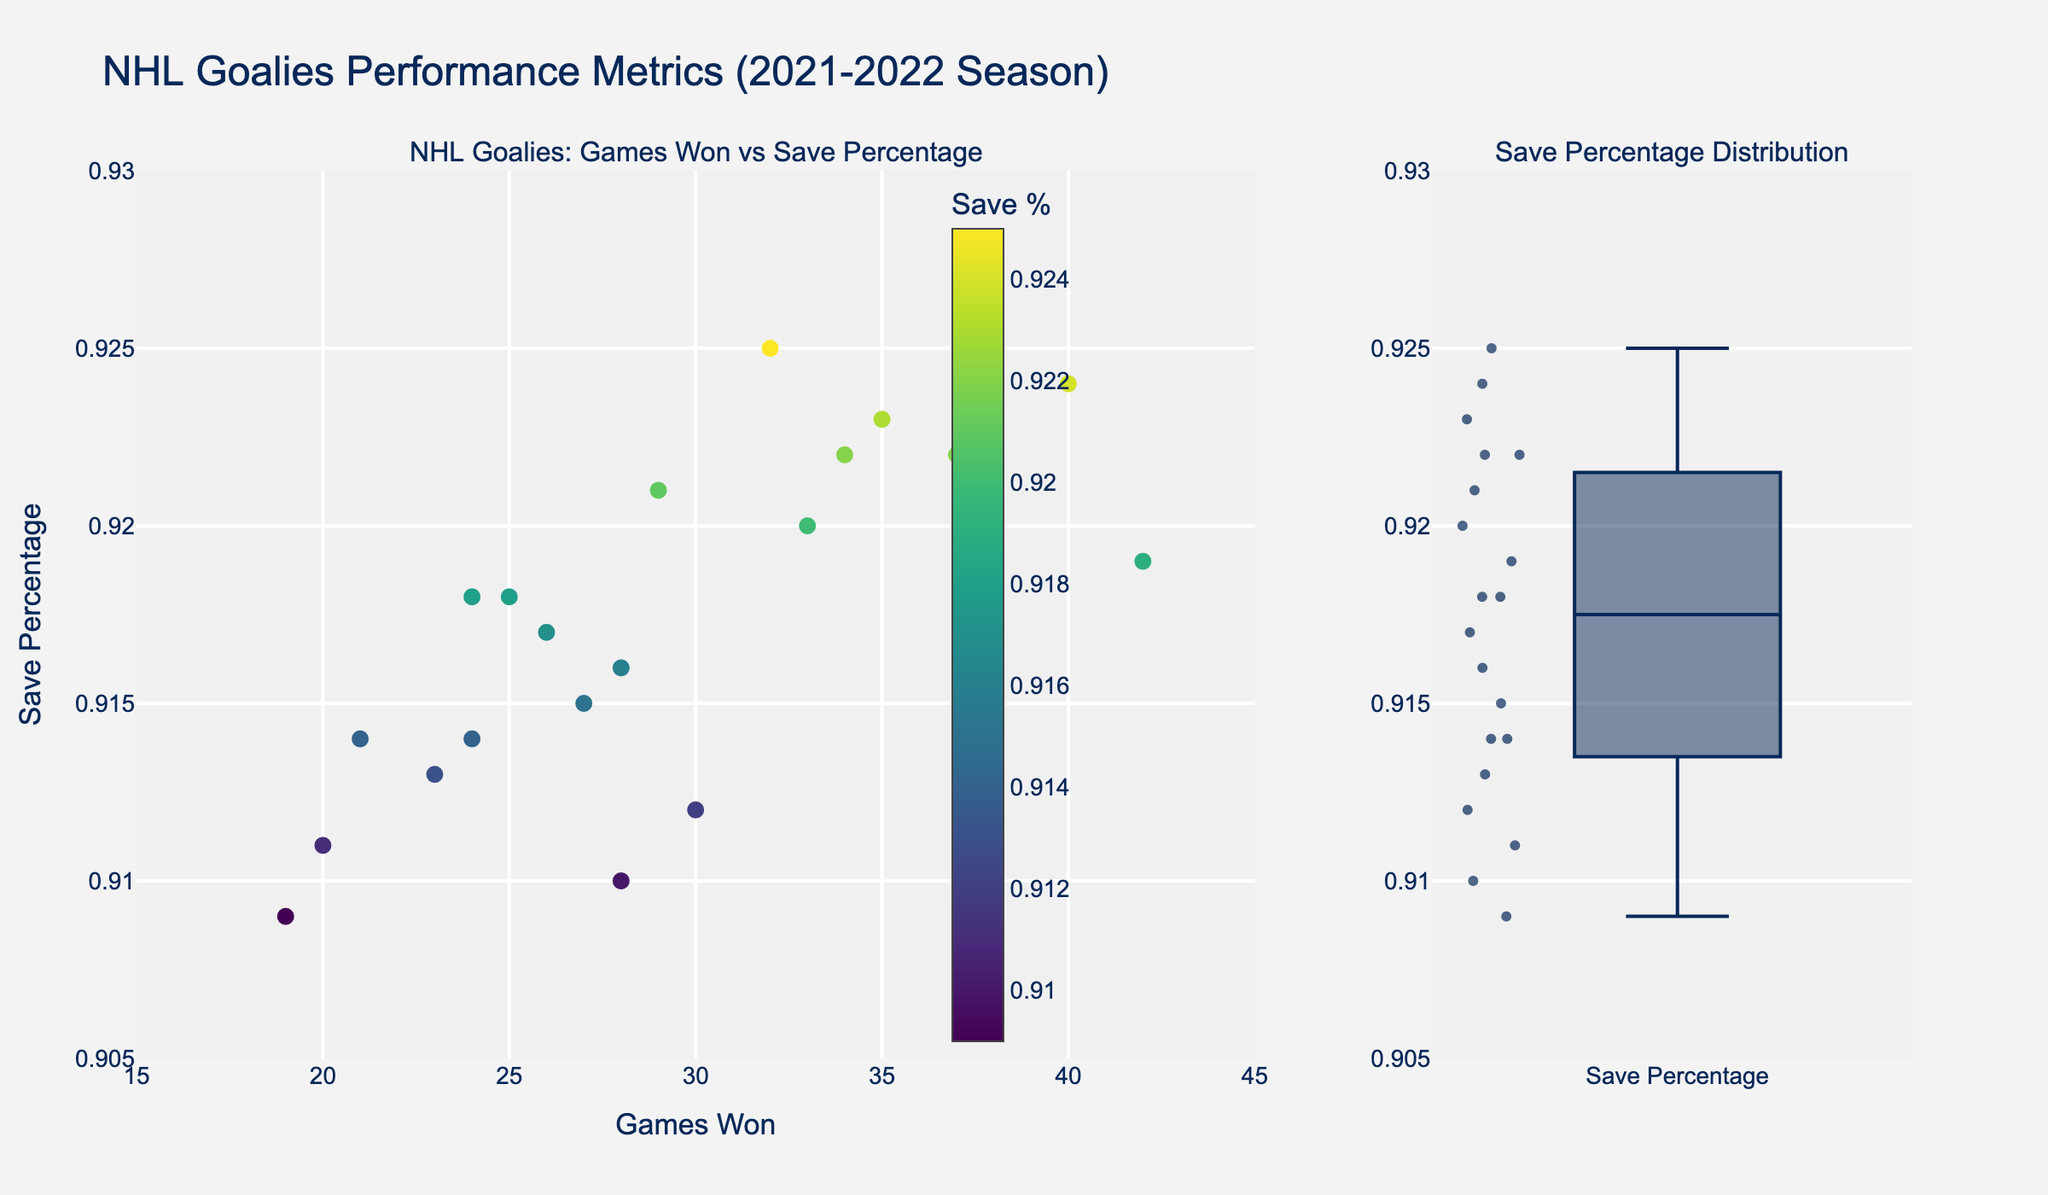what is the title of the plot? The title is the text displayed at the top of the plot. It describes the overview of what is being visualized.
Answer: NHL Goalies Performance Metrics (2021-2022 Season) How many goalies have their save percentage above 0.92? Look at the scatter plot for points above the 0.92 line. Alternatively, also check the save percentages distribution box plot and count the points above 0.92.
Answer: 7 Who has the highest save percentage? Identify the point closest to the upper y-axis boundary in both plots, scatter plot with goalie names and box plot showing all data points.
Answer: Ilya Sorokin What is the range of Games Won in the scatter plot? Examine the x-axis from the minimum to maximum points in the scatter plot for Games Won.
Answer: 19 to 42 Which goalie has won the most games? Identify the point farthest to the right on the x-axis in the scatter plot, and check the name associated.
Answer: Andrei Vasilevskiy What is the median save percentage according to the box plot? Look at the line inside the box of the Save Percentage box plot. This line represents the median value of the data.
Answer: Approximately 0.917 How does the save percentage of Igor Shesterkin compare to Frederik Andersen? Compare the y-values of Igor Shesterkin and Frederik Andersen in the scatter plot.
Answer: Igor Shesterkin's save percentage is higher Which goalie's save percentage is closest to the average save percentage? Calculate the average save percentage from all points plotted in the Save Percentage box plot by visually approximating the middle of the data spread. Compare individual points to determine proximity.
Answer: Tuukka Rask What is the color used to denote save percentage in the scatter plot color scale? Check the colorbar alongside the scatter plot indicating the scale.
Answer: Viridis colorscale Are there any goalies with identical save percentages? Look for overlapping points in the scatter plot or closely positioned points in the box plot segment.
Answer: Yes, Tuukka Rask and Carter Hart both have a save percentage of 0.914 